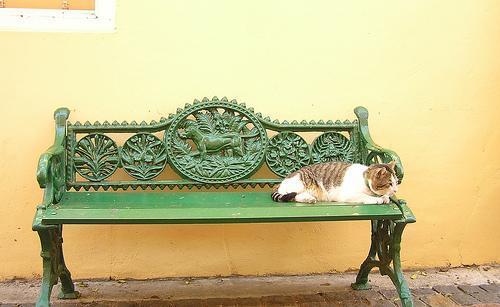How many cats sitting on the bench?
Give a very brief answer. 1. 